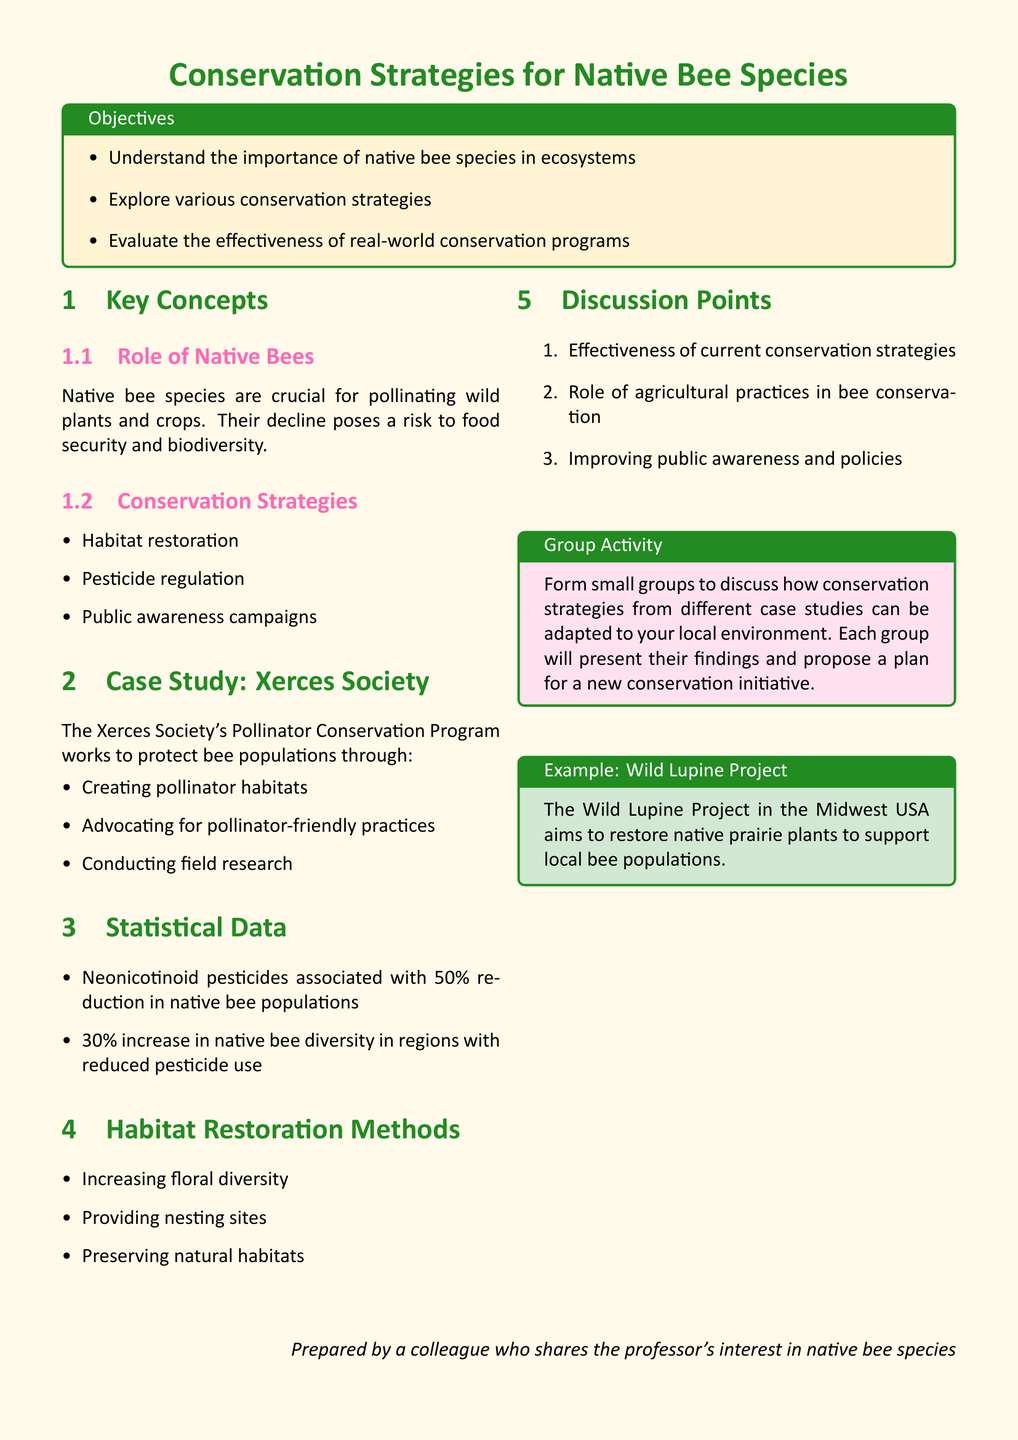What is the primary focus of the lesson plan? The lesson plan focuses on discussing conservation strategies for native bee species.
Answer: Conservation Strategies for Native Bee Species What are two conservation strategies mentioned in the document? The document lists several conservation strategies, two of which are habitat restoration and pesticide regulation.
Answer: Habitat restoration, pesticide regulation What percentage reduction in native bee populations is associated with neonicotinoid pesticides? The document states that neonicotinoid pesticides are associated with a 50% reduction in native bee populations.
Answer: 50% What increase in native bee diversity was observed in regions with reduced pesticide use? The document indicates a 30% increase in native bee diversity in regions with reduced pesticide use.
Answer: 30% What is one method of habitat restoration described in the lesson plan? The lesson plan describes several methods, including increasing floral diversity.
Answer: Increasing floral diversity Who is responsible for the Pollinator Conservation Program? The document mentions the Xerces Society as the organization responsible for this program.
Answer: Xerces Society What is one discussion point in the lesson plan? The lesson plan includes several discussion points, one of which is the effectiveness of current conservation strategies.
Answer: Effectiveness of current conservation strategies What is the group activity task in the lesson plan? The group activity involves discussing how conservation strategies from different case studies can be adapted to local environments.
Answer: Discuss how conservation strategies can be adapted to local environments What project aims to restore native prairie plants for bee support? The document mentions the Wild Lupine Project as an example aiming to restore native prairie plants.
Answer: Wild Lupine Project 